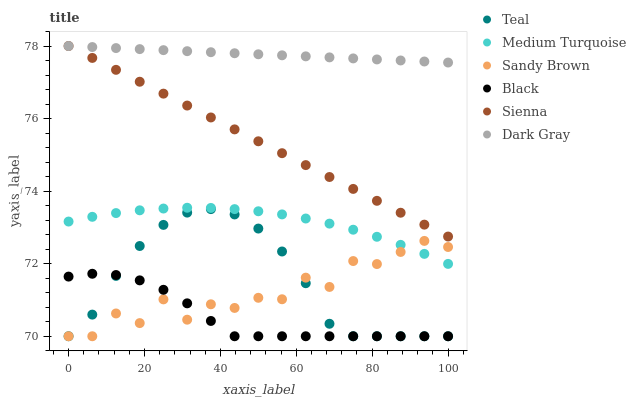Does Black have the minimum area under the curve?
Answer yes or no. Yes. Does Dark Gray have the maximum area under the curve?
Answer yes or no. Yes. Does Teal have the minimum area under the curve?
Answer yes or no. No. Does Teal have the maximum area under the curve?
Answer yes or no. No. Is Dark Gray the smoothest?
Answer yes or no. Yes. Is Sandy Brown the roughest?
Answer yes or no. Yes. Is Teal the smoothest?
Answer yes or no. No. Is Teal the roughest?
Answer yes or no. No. Does Teal have the lowest value?
Answer yes or no. Yes. Does Sienna have the lowest value?
Answer yes or no. No. Does Sienna have the highest value?
Answer yes or no. Yes. Does Teal have the highest value?
Answer yes or no. No. Is Teal less than Sienna?
Answer yes or no. Yes. Is Sienna greater than Medium Turquoise?
Answer yes or no. Yes. Does Teal intersect Black?
Answer yes or no. Yes. Is Teal less than Black?
Answer yes or no. No. Is Teal greater than Black?
Answer yes or no. No. Does Teal intersect Sienna?
Answer yes or no. No. 